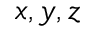Convert formula to latex. <formula><loc_0><loc_0><loc_500><loc_500>x , y , z</formula> 